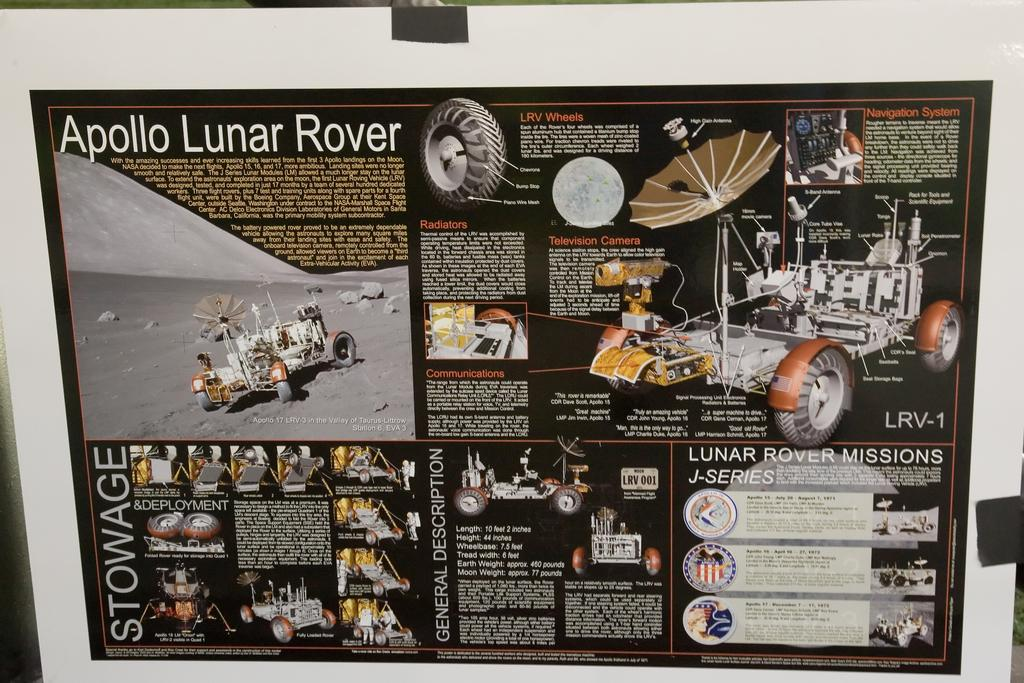<image>
Provide a brief description of the given image. a box for an apollo lunar rover with photos 